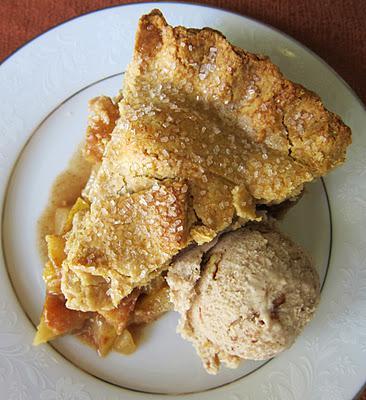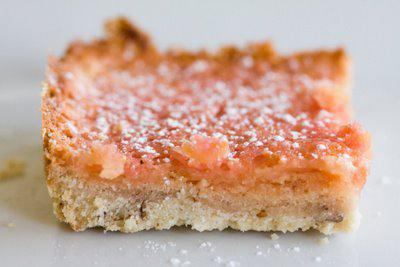The first image is the image on the left, the second image is the image on the right. For the images shown, is this caption "In one of the images, there is a piece of fresh lemon sitting beside the dough." true? Answer yes or no. No. The first image is the image on the left, the second image is the image on the right. Examine the images to the left and right. Is the description "there is cake with lemons being used as decorations and a metal utencil is near the cake" accurate? Answer yes or no. No. 